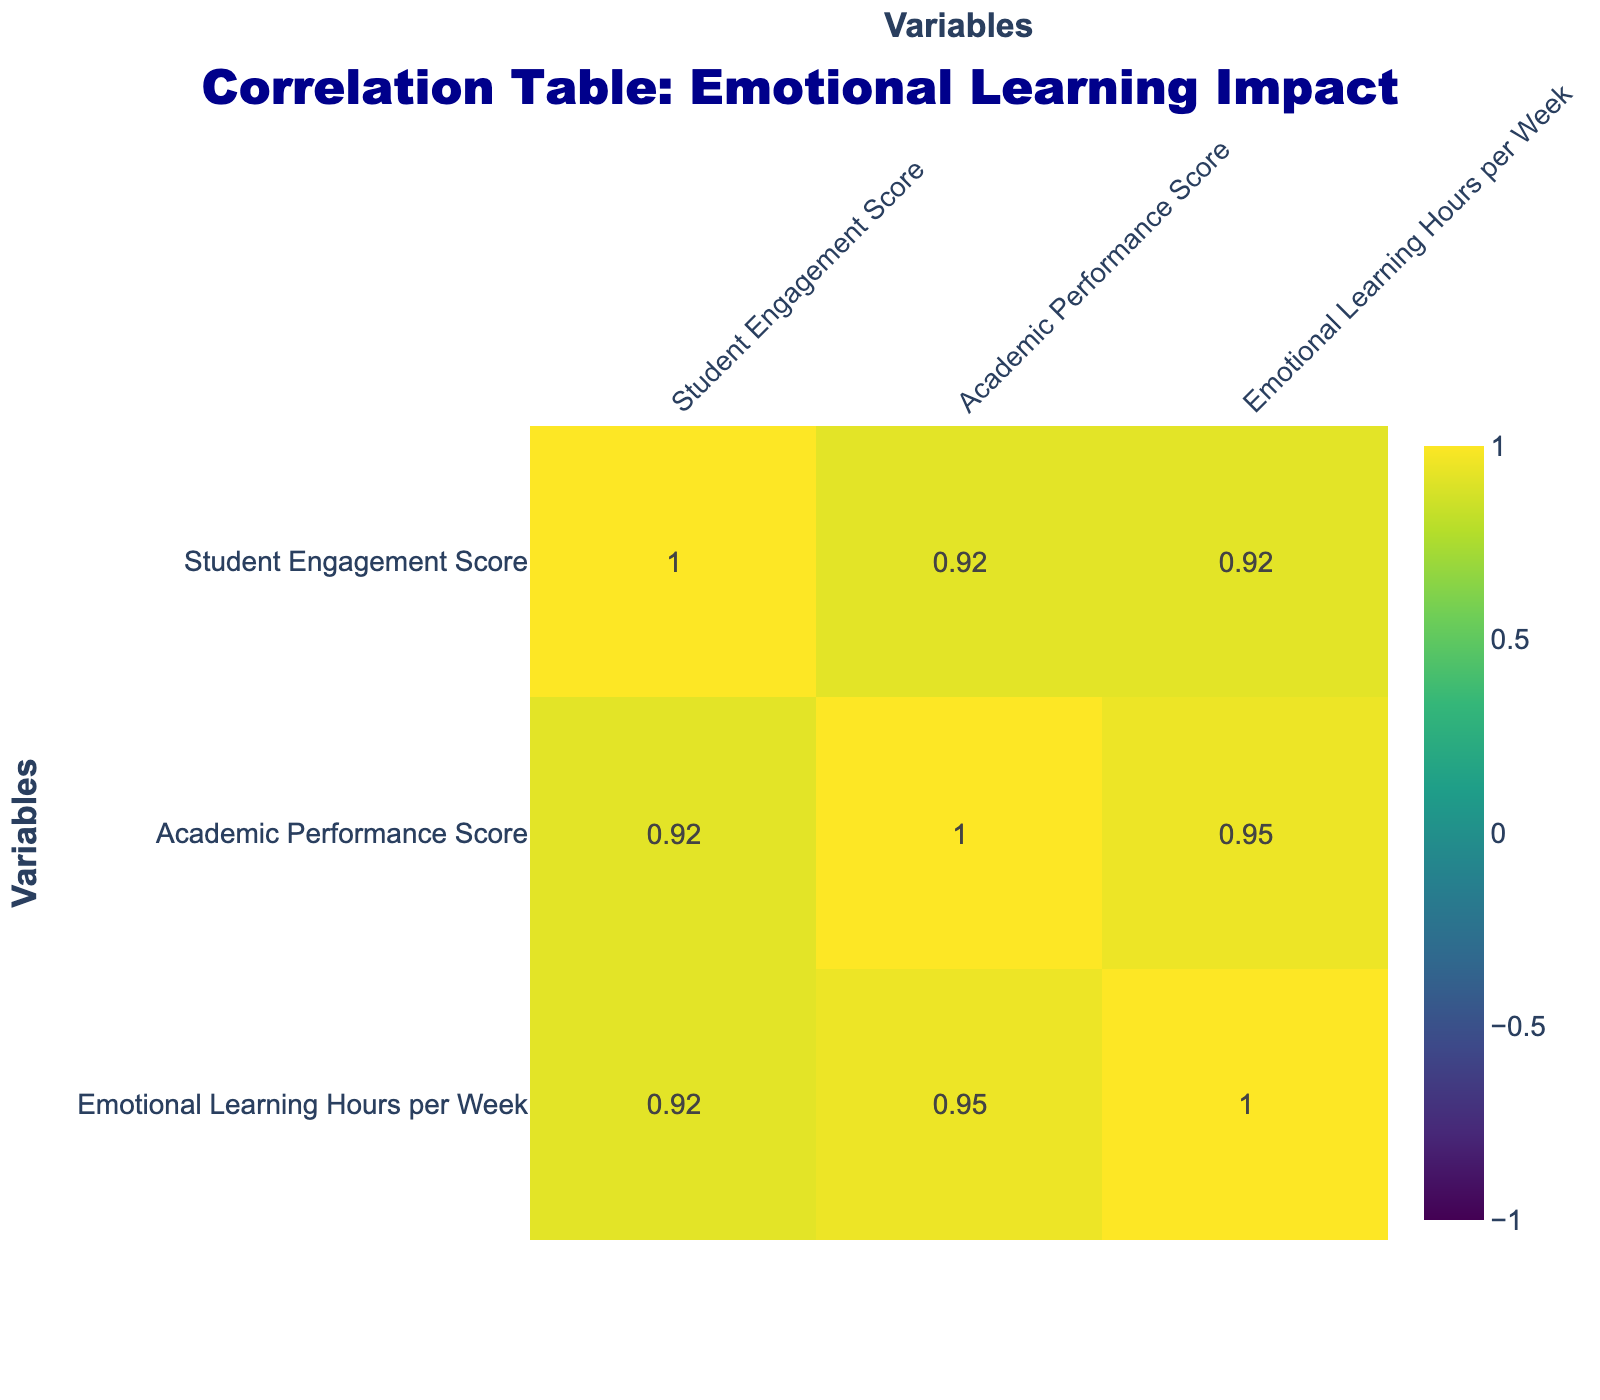What is the Student Engagement Score for the Resilience in Action program? The Student Engagement Score for the Resilience in Action program, as listed in the table, is 92.
Answer: 92 Is there a correlation between Emotional Learning Hours per Week and Academic Performance Score? To determine this, we can look at the correlation value between these two variables in the table. Since it is positive, it suggests that higher emotional learning hours correlate with better academic performance.
Answer: Yes What is the average Student Engagement Score for all programs? To calculate the average, we sum all the Student Engagement Scores: (85 + 78 + 90 + 75 + 88 + 82 + 79 + 92 + 87 + 83) = 855, and then divide by the number of programs, which is 10. So, 855/10 = 85.5.
Answer: 85.5 Which program has the highest Academic Performance Score? By scanning through the Academic Performance Scores in the table, we find that the Resilience in Action program has the highest score of 94.
Answer: 94 Does the EmpowerED program have more Emotional Learning Hours per Week than the Positive Impact program? The table shows that EmpowerED has 4 hours of emotional learning per week, while Positive Impact has 2 hours. Since 4 is greater than 2, the EmpowerED program does have more hours.
Answer: Yes What is the difference between the highest and lowest Student Engagement Scores? The highest Student Engagement Score is 92 (Resilience in Action) and the lowest is 75 (Social-Emotional Learning Program). To find the difference, we subtract: 92 - 75 = 17.
Answer: 17 Which program has the lowest Emotional Learning Hours per Week? Looking through the table, the Social-Emotional Learning Program and Positive Impact both have the lowest at 2 hours per week.
Answer: 2 What is the total Academic Performance Score for all programs combined? Adding up all the Academic Performance Scores from the table gives us: 88 + 82 + 91 + 80 + 85 + 83 + 81 + 94 + 89 + 84 =  5. The total Academic Performance Score is  5.
Answer: 5 Is it true that all programs with more than 3 Emotional Learning Hours per Week have Student Engagement Scores above 85? Checking the table, the programs with more than 3 hours are EmpowerED, Resilience in Action, and Compassionate Classrooms, and their Student Engagement Scores are 90, 92, and 87 respectively, all above 85. Therefore, the statement is true.
Answer: Yes 